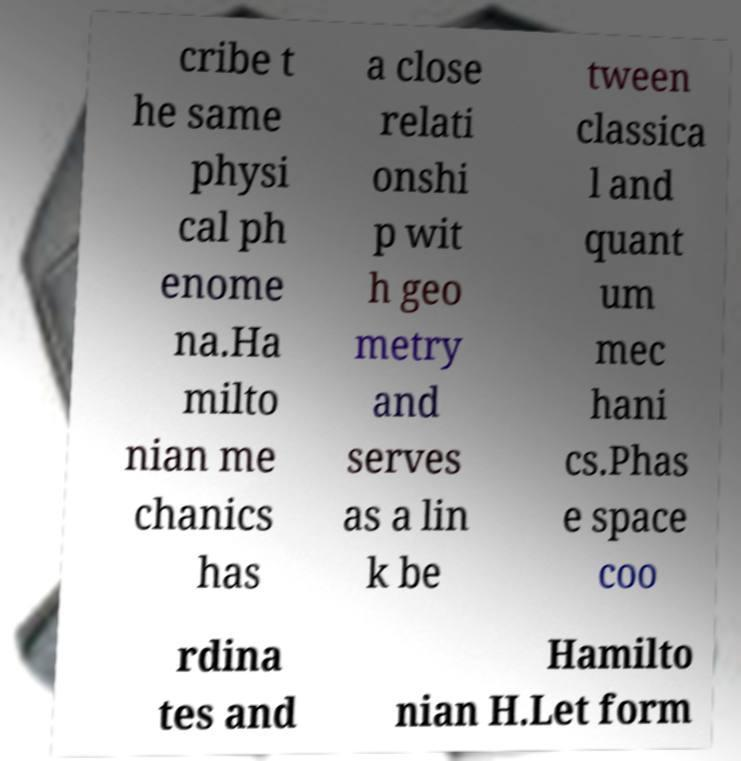Could you assist in decoding the text presented in this image and type it out clearly? cribe t he same physi cal ph enome na.Ha milto nian me chanics has a close relati onshi p wit h geo metry and serves as a lin k be tween classica l and quant um mec hani cs.Phas e space coo rdina tes and Hamilto nian H.Let form 